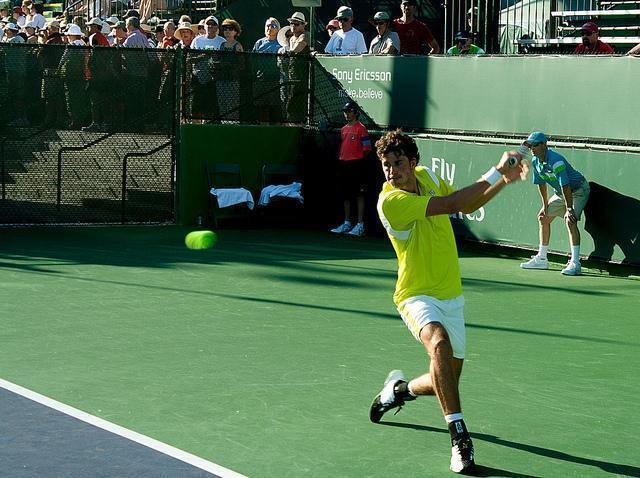Who are the people standing behind the gate?
Indicate the correct response and explain using: 'Answer: answer
Rationale: rationale.'
Options: Coaches, travelers, spectators, jury. Answer: spectators.
Rationale: There are spectators watching. 